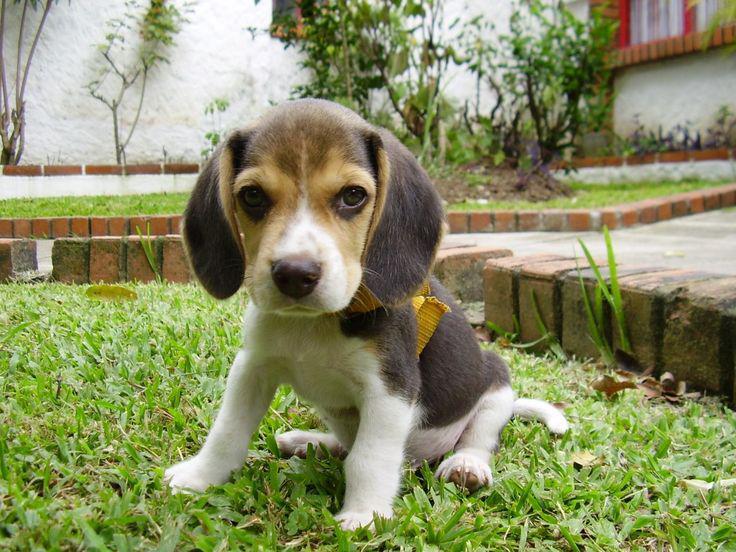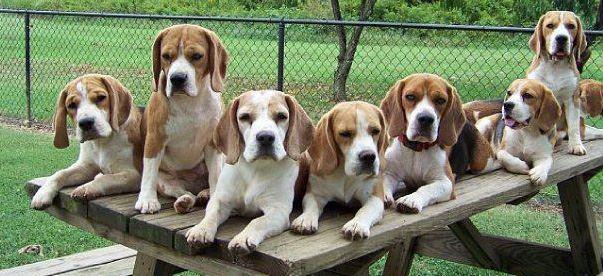The first image is the image on the left, the second image is the image on the right. For the images shown, is this caption "An image contains exactly one dog, a beagle puppy that is sitting on green grass." true? Answer yes or no. Yes. The first image is the image on the left, the second image is the image on the right. For the images displayed, is the sentence "The right image contains no more than three dogs." factually correct? Answer yes or no. No. 